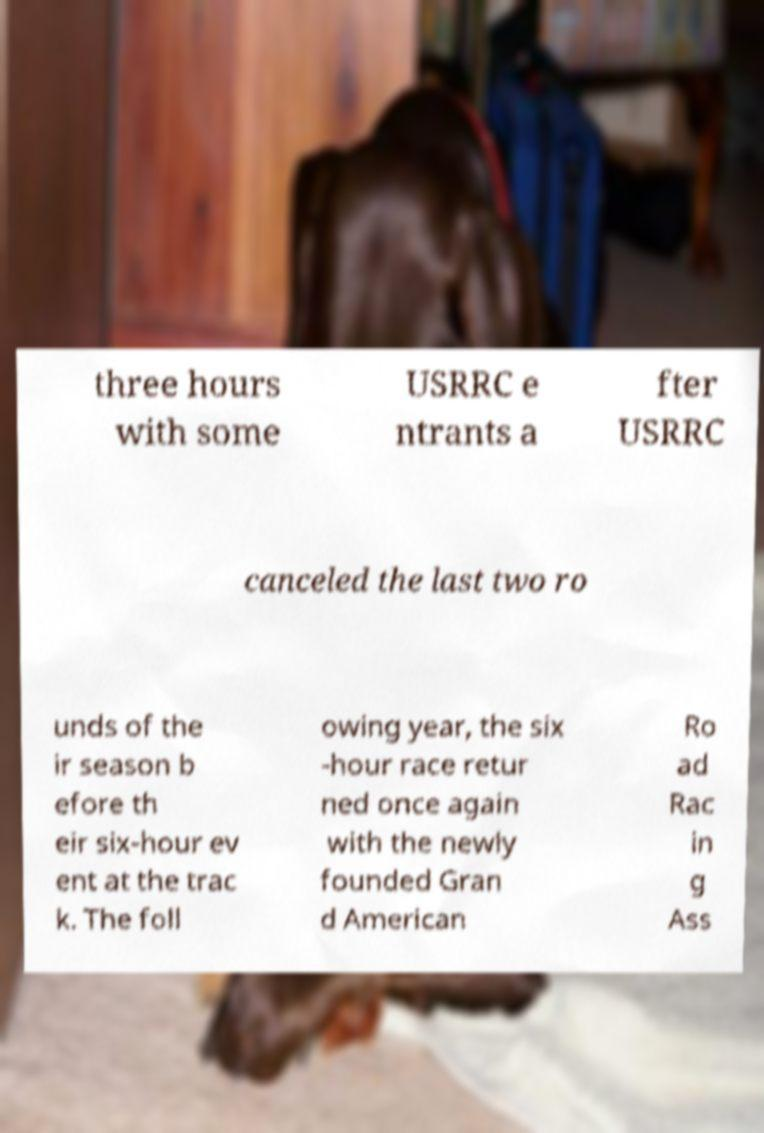For documentation purposes, I need the text within this image transcribed. Could you provide that? three hours with some USRRC e ntrants a fter USRRC canceled the last two ro unds of the ir season b efore th eir six-hour ev ent at the trac k. The foll owing year, the six -hour race retur ned once again with the newly founded Gran d American Ro ad Rac in g Ass 